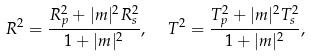Convert formula to latex. <formula><loc_0><loc_0><loc_500><loc_500>R ^ { 2 } = \frac { R _ { p } ^ { 2 } + | m | ^ { 2 } R _ { s } ^ { 2 } } { 1 + | m | ^ { 2 } } , \ \ T ^ { 2 } = \frac { T _ { p } ^ { 2 } + | m | ^ { 2 } T _ { s } ^ { 2 } } { 1 + | m | ^ { 2 } } ,</formula> 